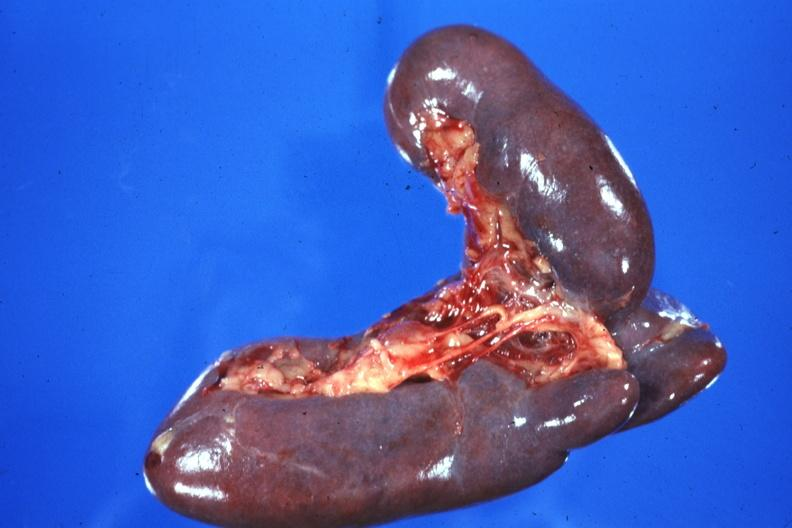where is this part in?
Answer the question using a single word or phrase. Spleen 